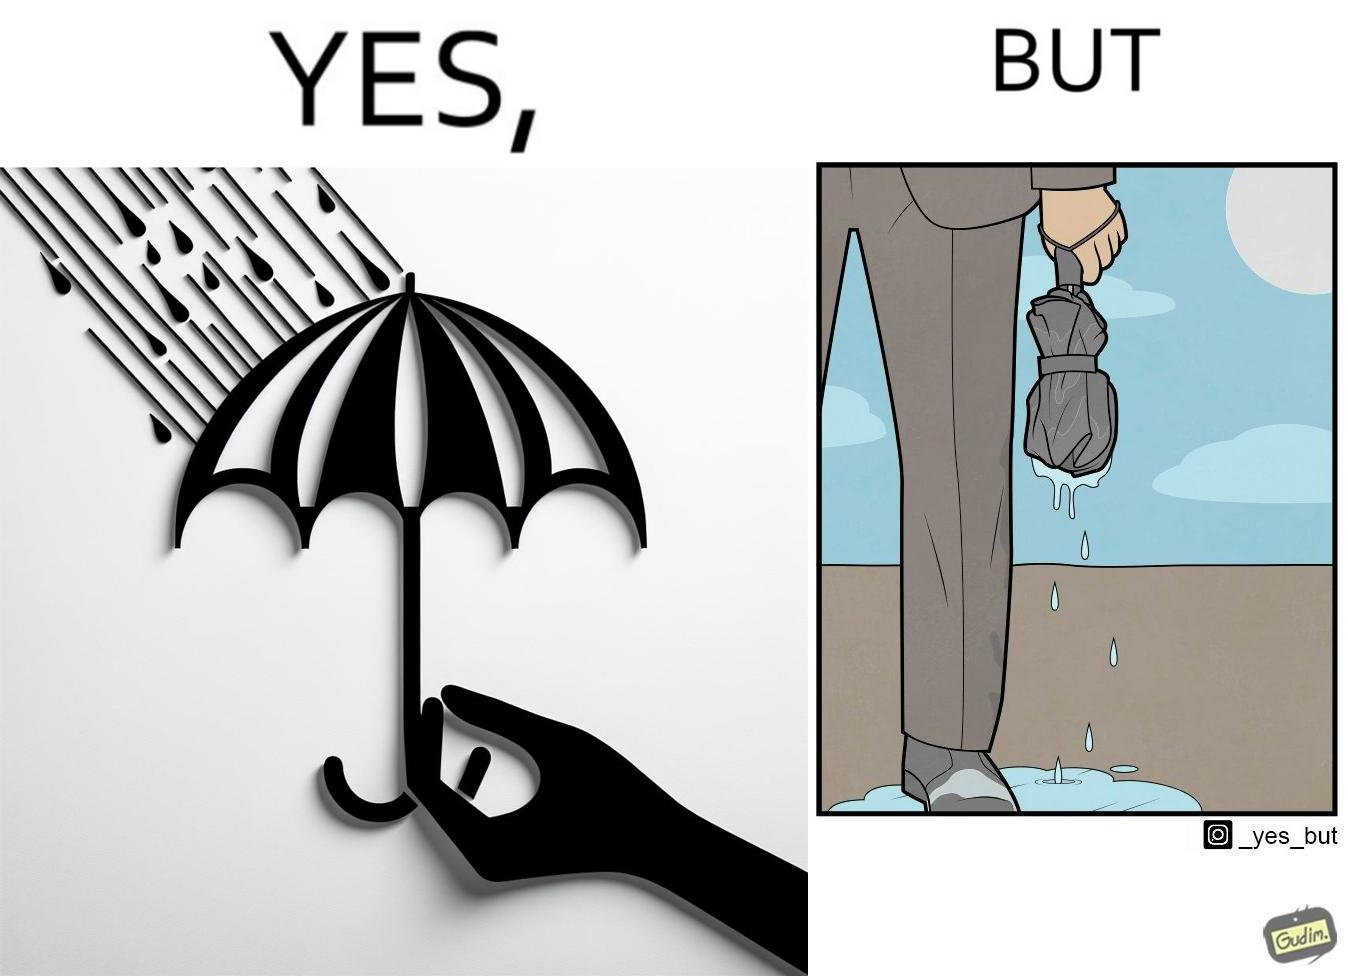What do you see in each half of this image? In the left part of the image: The image shows a hand holding an open black umbrella during rain. The open umbrella is stopping the raindrops to fall below it. In the right part of the image: The image shows water dripping from a wet, folded umberlla in a man's hand. The water is all over the man's shoe and the floor around it. 